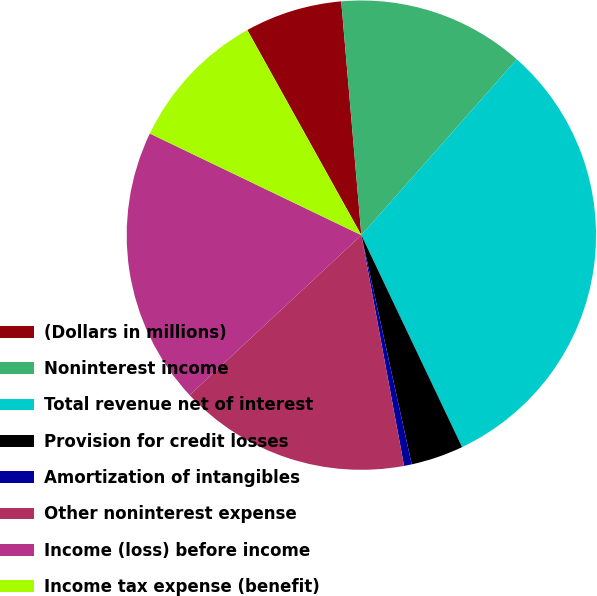<chart> <loc_0><loc_0><loc_500><loc_500><pie_chart><fcel>(Dollars in millions)<fcel>Noninterest income<fcel>Total revenue net of interest<fcel>Provision for credit losses<fcel>Amortization of intangibles<fcel>Other noninterest expense<fcel>Income (loss) before income<fcel>Income tax expense (benefit)<nl><fcel>6.71%<fcel>12.89%<fcel>31.43%<fcel>3.62%<fcel>0.53%<fcel>15.98%<fcel>19.07%<fcel>9.8%<nl></chart> 